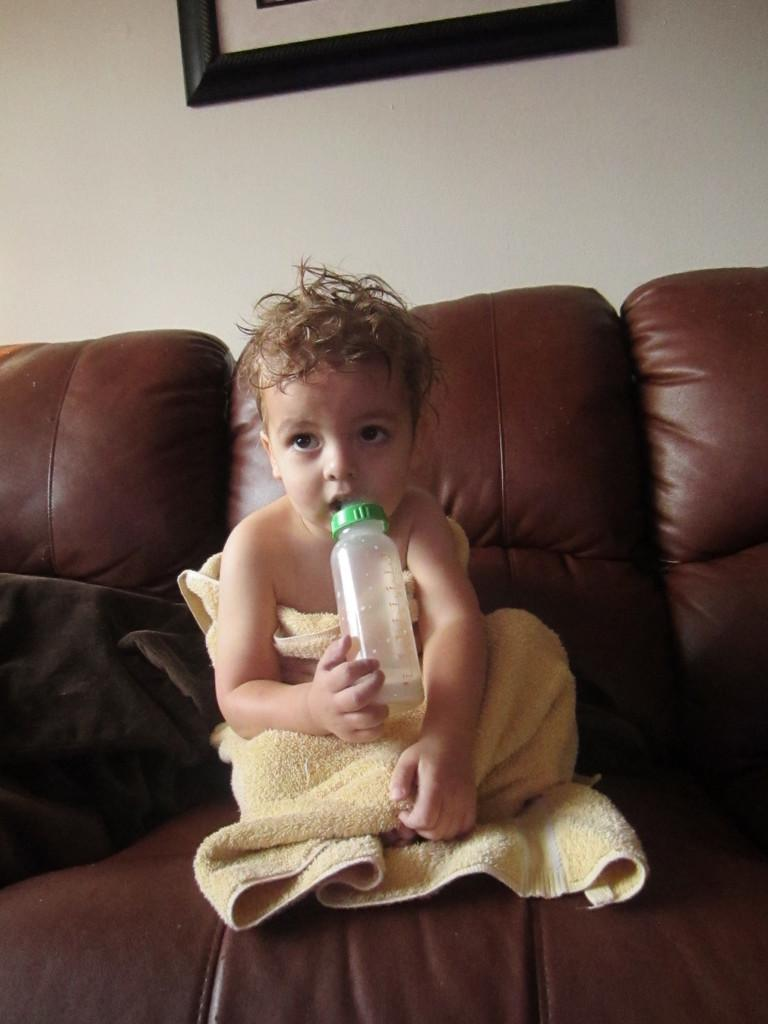What is the main subject of the image? There is a baby in the image. What is the baby holding in the image? The baby is holding a bottle. Where is the baby sitting in the image? The baby is sitting on a couch. What can be seen in the background of the image? There is a wall in the background of the image. What is on the wall in the image? There is a photo frame on the wall. What advice does the baby's grandfather give in the image? There is no grandfather present in the image, so it is not possible to answer that question. 